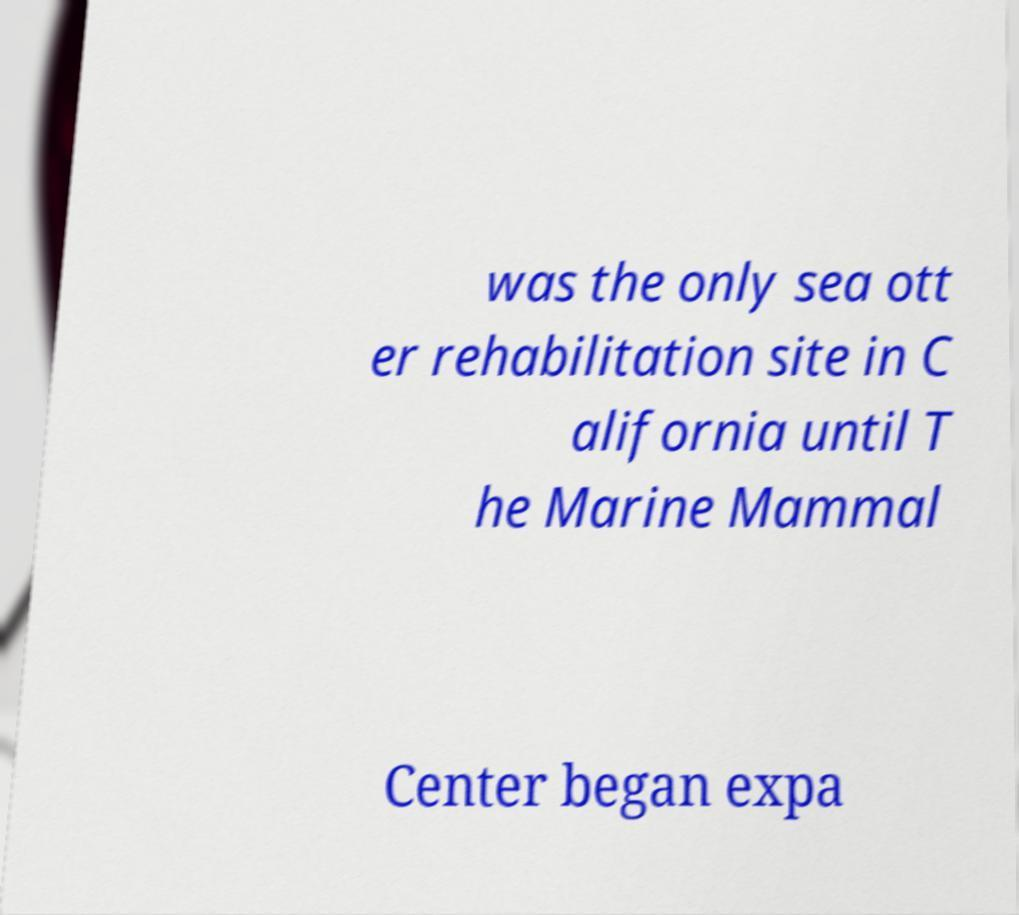Could you extract and type out the text from this image? was the only sea ott er rehabilitation site in C alifornia until T he Marine Mammal Center began expa 